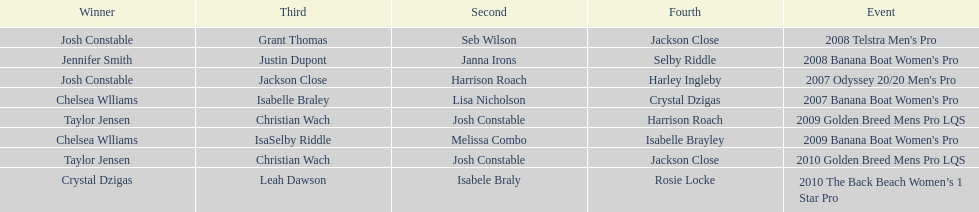In what two races did chelsea williams earn the same rank? 2007 Banana Boat Women's Pro, 2009 Banana Boat Women's Pro. 